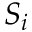<formula> <loc_0><loc_0><loc_500><loc_500>S _ { i }</formula> 